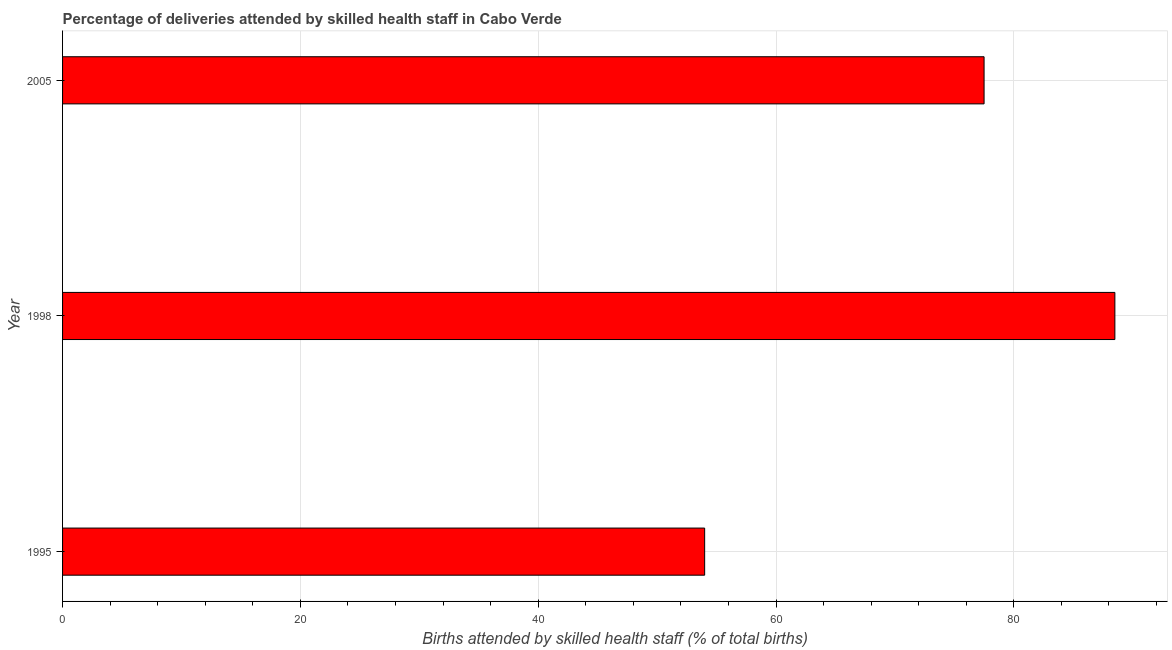What is the title of the graph?
Give a very brief answer. Percentage of deliveries attended by skilled health staff in Cabo Verde. What is the label or title of the X-axis?
Your response must be concise. Births attended by skilled health staff (% of total births). What is the label or title of the Y-axis?
Offer a very short reply. Year. Across all years, what is the maximum number of births attended by skilled health staff?
Give a very brief answer. 88.5. What is the sum of the number of births attended by skilled health staff?
Make the answer very short. 220. What is the difference between the number of births attended by skilled health staff in 1995 and 1998?
Ensure brevity in your answer.  -34.5. What is the average number of births attended by skilled health staff per year?
Ensure brevity in your answer.  73.33. What is the median number of births attended by skilled health staff?
Your response must be concise. 77.5. In how many years, is the number of births attended by skilled health staff greater than 32 %?
Provide a succinct answer. 3. What is the ratio of the number of births attended by skilled health staff in 1995 to that in 2005?
Provide a succinct answer. 0.7. Is the number of births attended by skilled health staff in 1998 less than that in 2005?
Ensure brevity in your answer.  No. What is the difference between the highest and the lowest number of births attended by skilled health staff?
Give a very brief answer. 34.5. In how many years, is the number of births attended by skilled health staff greater than the average number of births attended by skilled health staff taken over all years?
Your answer should be very brief. 2. How many bars are there?
Make the answer very short. 3. What is the Births attended by skilled health staff (% of total births) in 1995?
Offer a very short reply. 54. What is the Births attended by skilled health staff (% of total births) in 1998?
Ensure brevity in your answer.  88.5. What is the Births attended by skilled health staff (% of total births) of 2005?
Provide a succinct answer. 77.5. What is the difference between the Births attended by skilled health staff (% of total births) in 1995 and 1998?
Offer a very short reply. -34.5. What is the difference between the Births attended by skilled health staff (% of total births) in 1995 and 2005?
Offer a very short reply. -23.5. What is the ratio of the Births attended by skilled health staff (% of total births) in 1995 to that in 1998?
Offer a terse response. 0.61. What is the ratio of the Births attended by skilled health staff (% of total births) in 1995 to that in 2005?
Make the answer very short. 0.7. What is the ratio of the Births attended by skilled health staff (% of total births) in 1998 to that in 2005?
Your response must be concise. 1.14. 